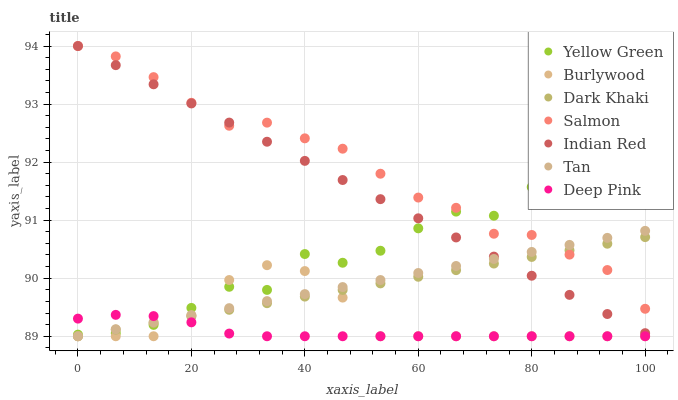Does Deep Pink have the minimum area under the curve?
Answer yes or no. Yes. Does Salmon have the maximum area under the curve?
Answer yes or no. Yes. Does Yellow Green have the minimum area under the curve?
Answer yes or no. No. Does Yellow Green have the maximum area under the curve?
Answer yes or no. No. Is Tan the smoothest?
Answer yes or no. Yes. Is Yellow Green the roughest?
Answer yes or no. Yes. Is Burlywood the smoothest?
Answer yes or no. No. Is Burlywood the roughest?
Answer yes or no. No. Does Deep Pink have the lowest value?
Answer yes or no. Yes. Does Yellow Green have the lowest value?
Answer yes or no. No. Does Indian Red have the highest value?
Answer yes or no. Yes. Does Yellow Green have the highest value?
Answer yes or no. No. Is Deep Pink less than Salmon?
Answer yes or no. Yes. Is Indian Red greater than Deep Pink?
Answer yes or no. Yes. Does Deep Pink intersect Burlywood?
Answer yes or no. Yes. Is Deep Pink less than Burlywood?
Answer yes or no. No. Is Deep Pink greater than Burlywood?
Answer yes or no. No. Does Deep Pink intersect Salmon?
Answer yes or no. No. 